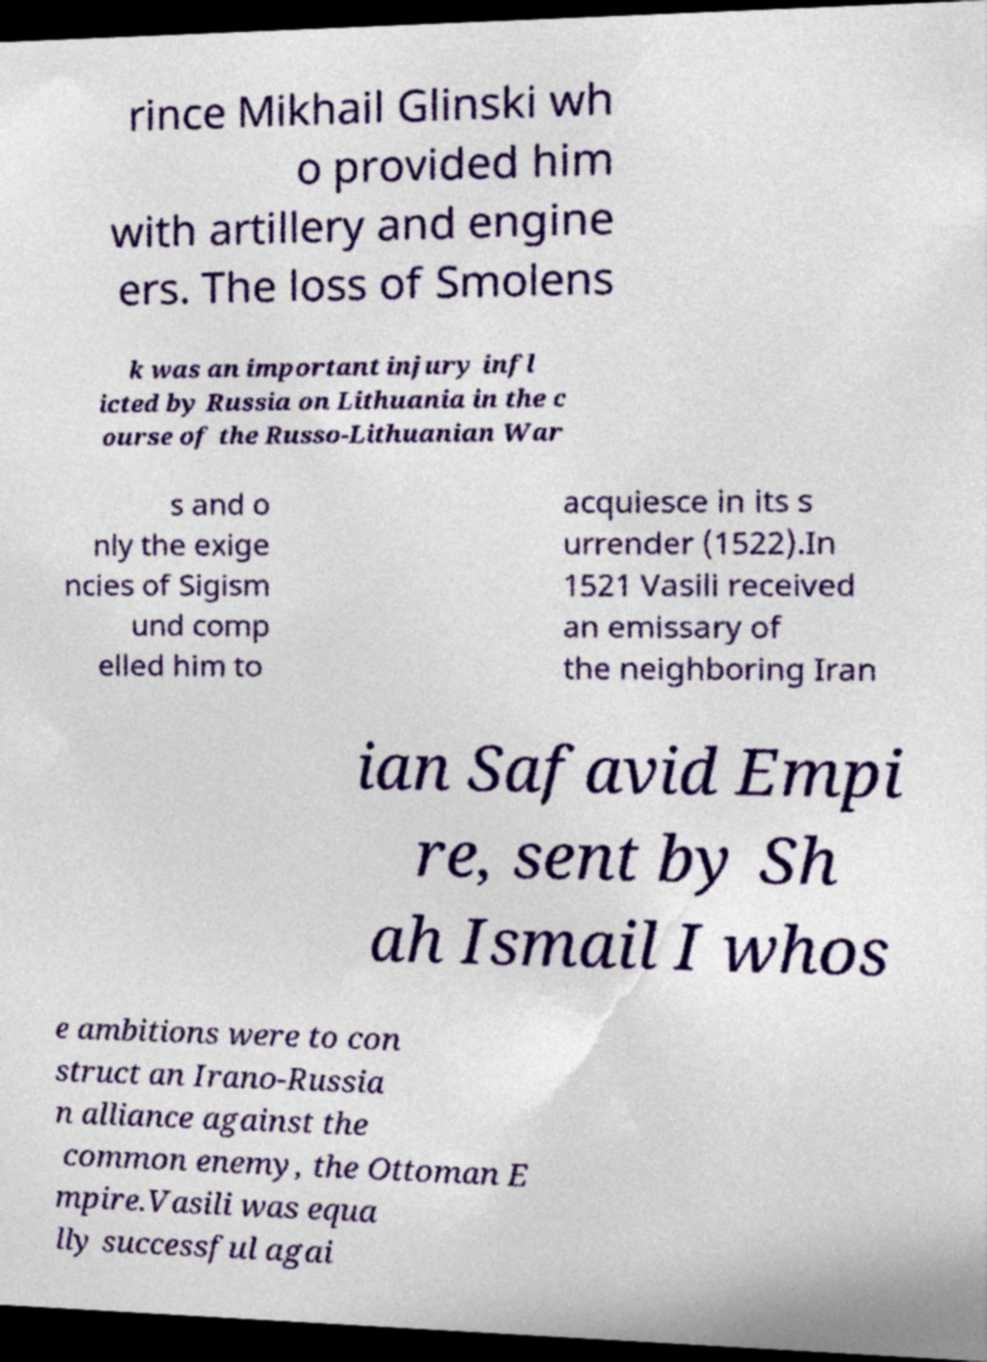What messages or text are displayed in this image? I need them in a readable, typed format. rince Mikhail Glinski wh o provided him with artillery and engine ers. The loss of Smolens k was an important injury infl icted by Russia on Lithuania in the c ourse of the Russo-Lithuanian War s and o nly the exige ncies of Sigism und comp elled him to acquiesce in its s urrender (1522).In 1521 Vasili received an emissary of the neighboring Iran ian Safavid Empi re, sent by Sh ah Ismail I whos e ambitions were to con struct an Irano-Russia n alliance against the common enemy, the Ottoman E mpire.Vasili was equa lly successful agai 